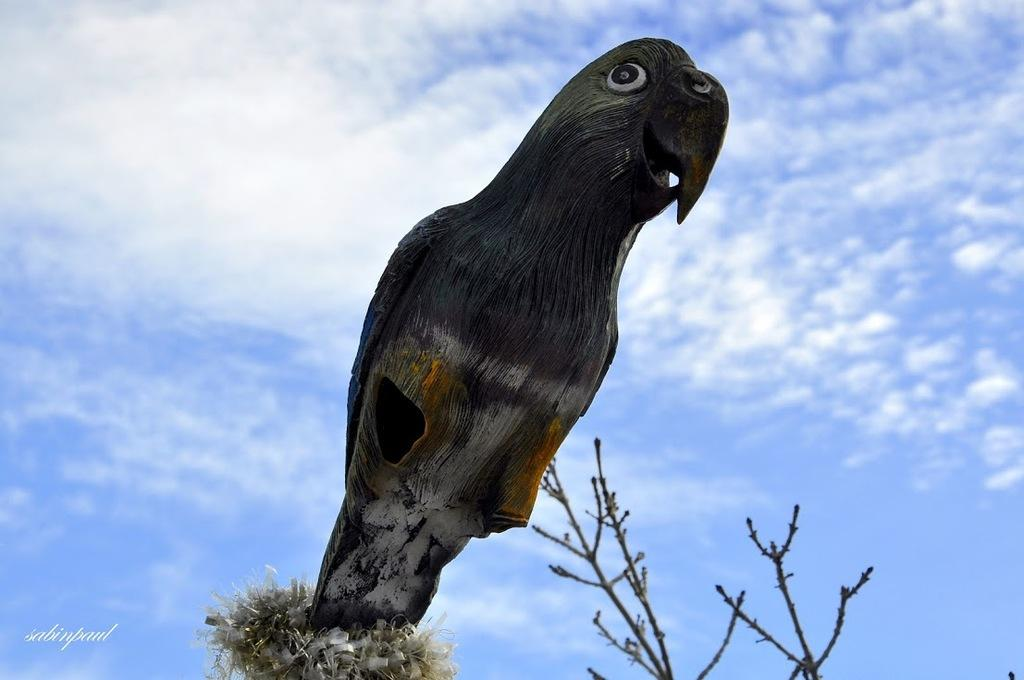What is the main subject of the image? There is a sculpture of a bird in the image. What can be seen at the right bottom of the image? There are branches at the right bottom of the image. What is visible in the background of the image? The background of the image includes the sky. What can be observed in the sky in the image? There are clouds visible in the sky. What type of curtain is hanging from the bird's beak in the image? There is no curtain present in the image, and the bird's beak is not depicted as holding any object. 